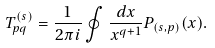Convert formula to latex. <formula><loc_0><loc_0><loc_500><loc_500>T ^ { ( s ) } _ { p q } = \frac { 1 } { 2 \pi i } \oint \frac { d x } { x ^ { q + 1 } } P _ { ( s , p ) } ( x ) .</formula> 